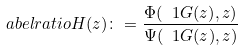Convert formula to latex. <formula><loc_0><loc_0><loc_500><loc_500>\L a b e l { r a t i o } H ( z ) \colon = \frac { \Phi ( \ 1 { G ( z ) } , z ) } { \Psi ( \ 1 { G ( z ) } , z ) }</formula> 